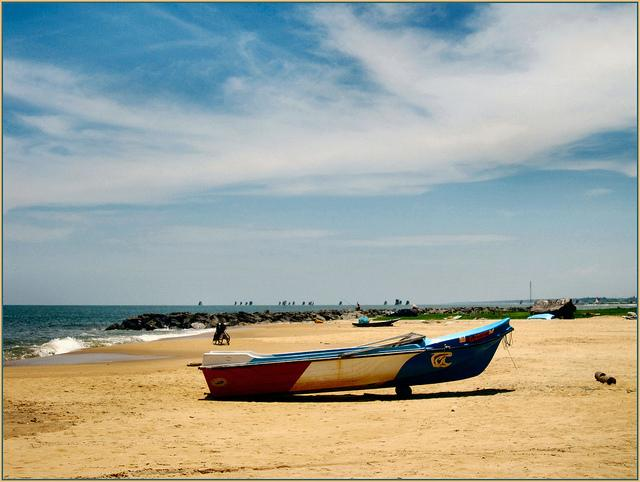Who might use the boat on the beach? Please explain your reasoning. lifeguards. The boat is for emergency use. 